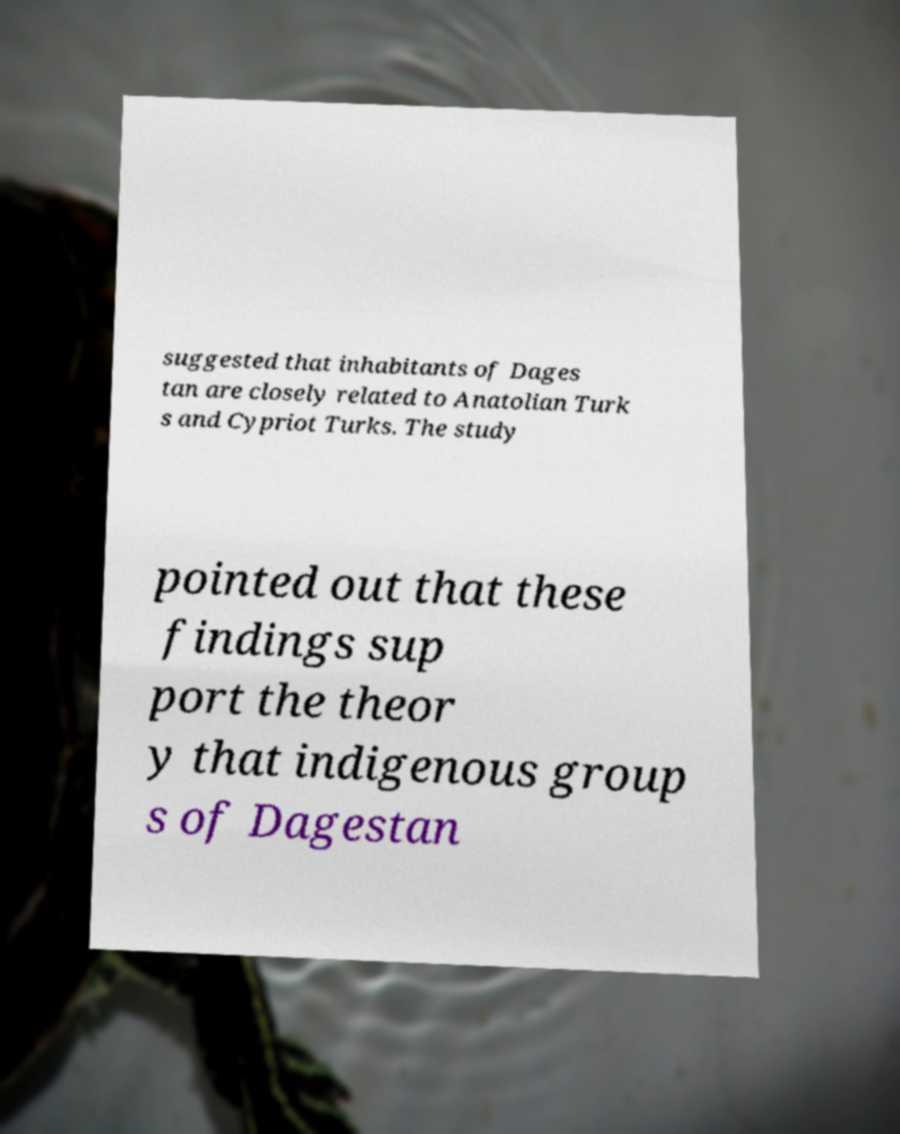Can you read and provide the text displayed in the image?This photo seems to have some interesting text. Can you extract and type it out for me? suggested that inhabitants of Dages tan are closely related to Anatolian Turk s and Cypriot Turks. The study pointed out that these findings sup port the theor y that indigenous group s of Dagestan 